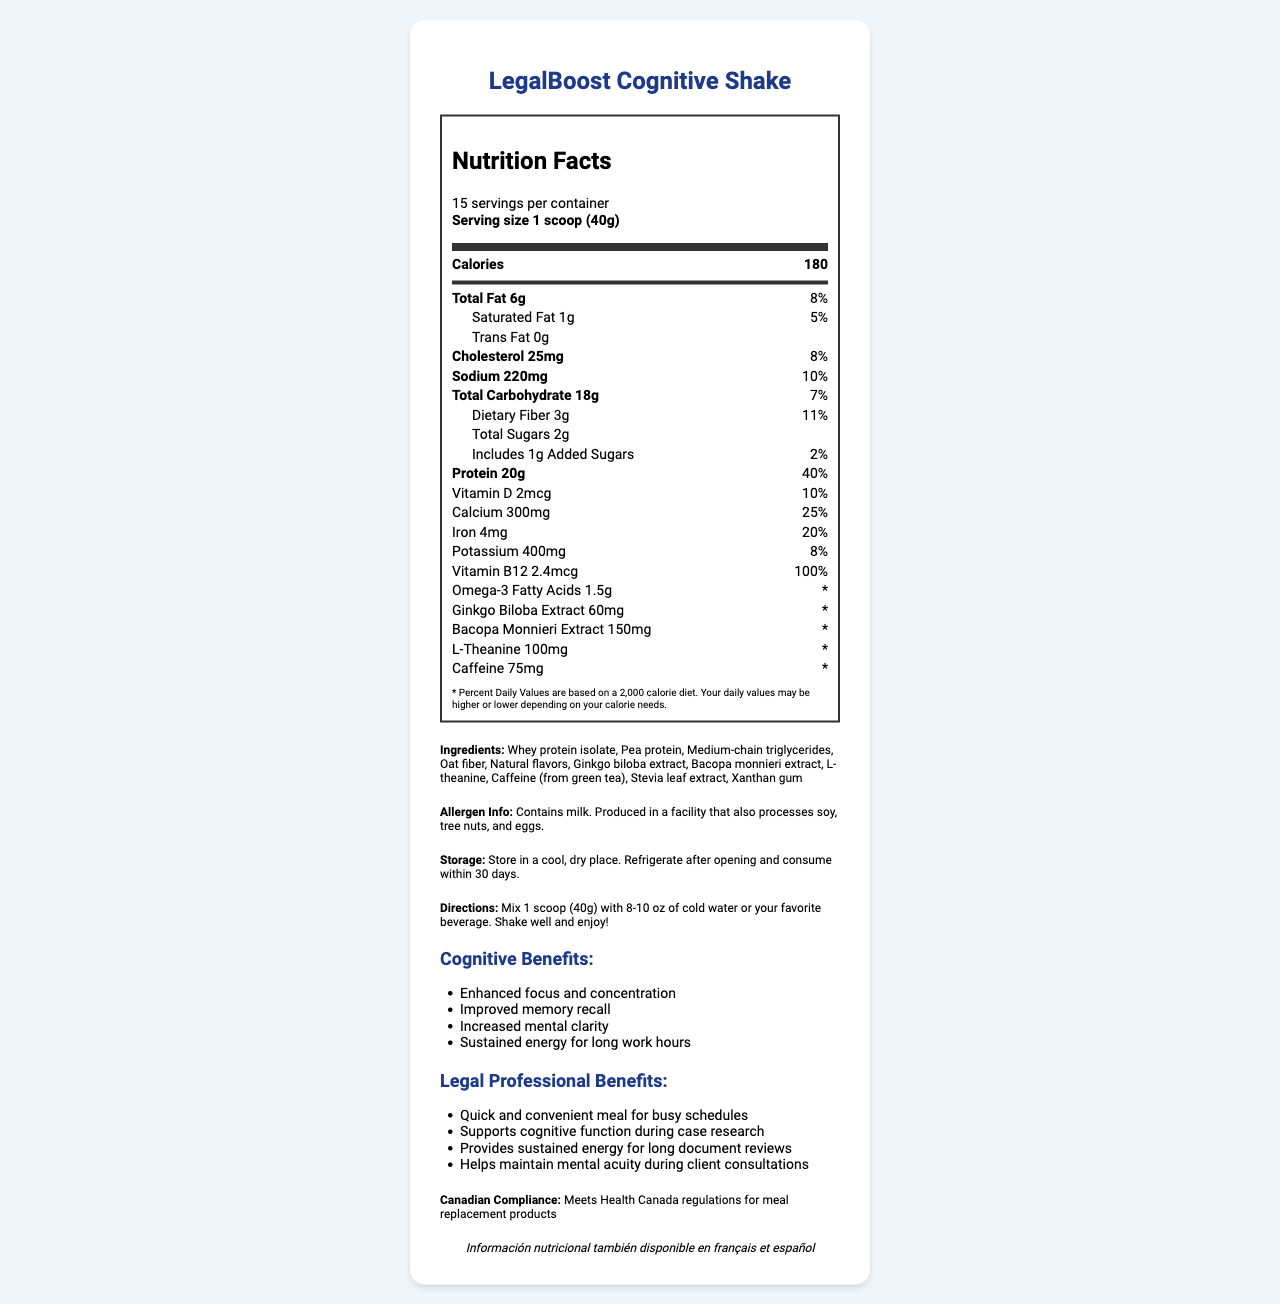what is the serving size? The serving size is explicitly mentioned as "1 scoop (40g)" in the serving info section of the nutrition label.
Answer: 1 scoop (40g) how many servings are in one container? The number of servings per container is mentioned as 15 in the serving info section.
Answer: 15 servings what is the total amount of protein in a serving? In the nutrient section, it is stated that there are 20g of protein in one serving.
Answer: 20g how much caffeine does the shake contain? The amount of caffeine is listed as 75mg in the nutrient section.
Answer: 75mg what are the primary ingredients of the shake? The ingredients are clearly listed under the Ingredients section in the document.
Answer: Whey protein isolate, Pea protein, Medium-chain triglycerides, Oat fiber, Natural flavors, Ginkgo biloba extract, Bacopa monnieri extract, L-theanine, Caffeine (from green tea), Stevia leaf extract, Xanthan gum how many calories are there per serving of the LegalBoost Cognitive Shake? The number of calories per serving is listed as 180 in the main info section.
Answer: 180 calories Which vitamin has the highest daily value percentage in LegalBoost Cognitive Shake? 1. Vitamin D 2. Calcium 3. Iron 4. Vitamin B12 The daily value for Vitamin B12 is 100%, which is higher than the daily values for all other vitamins listed.
Answer: 4. Vitamin B12 What is the daily value percentage for dietary fiber per serving? A. 11% B. 8% C. 10% D. 7% The daily value percentage for dietary fiber is 11%, as stated in the nutrient row detailing dietary fiber.
Answer: A. 11% Are there any trans fats in the LegalBoost Cognitive Shake? The document states that there are 0g of trans fats in the shake.
Answer: No Summarize the key cognitive benefits of the LegalBoost Cognitive Shake. The cognitive benefits section lists these four main cognitive benefits of the LegalBoost Cognitive Shake.
Answer: Enhanced focus and concentration, Improved memory recall, Increased mental clarity, Sustained energy for long work hours Is the product compliant with Health Canada regulations for meal replacement products? The Canadian Compliance section explicitly states that the product meets Health Canada regulations for meal replacement products.
Answer: Yes What are the potential allergens in the LegalBoost Cognitive Shake? The allergen info section states that it contains milk and is produced in a facility that also processes soy, tree nuts, and eggs.
Answer: Milk, Soy, Tree nuts, Eggs What should you do after opening the container of the shake mix? The storage instructions say to refrigerate after opening and consume within 30 days.
Answer: Refrigerate and consume within 30 days How should you prepare a serving of LegalBoost Cognitive Shake? The directions section provides these specific steps to prepare a serving.
Answer: Mix 1 scoop (40g) with 8-10 oz of cold water or your favorite beverage and shake well. What is the total sugar content in one serving? The total sugar content is listed as 2g in the nutrient sub-section.
Answer: 2g How does LegalBoost Cognitive Shake support legal professionals? A. Enhances physical strength B. Supports cognitive function during case research C. Helps in losing weight D. Increases sleep quality Under the Legal Professional Benefits section, it is mentioned that the shake supports cognitive function during case research.
Answer: B. Supports cognitive function during case research Does the document include storage information in multiple languages? The multilingual info section mentions that nutritional information is available in other languages, but does not mention storage instructions in those languages.
Answer: No What is the main idea of the document? The document details the product's nutritional information, ingredients, cognitive benefits, professional benefits, storage instructions, and compliance information, showcasing it as a supportive meal replacement for legal professionals.
Answer: The document provides the nutritional facts and benefits of the LegalBoost Cognitive Shake designed for legal professionals, emphasizing its cognitive benefits and regulatory compliance. 